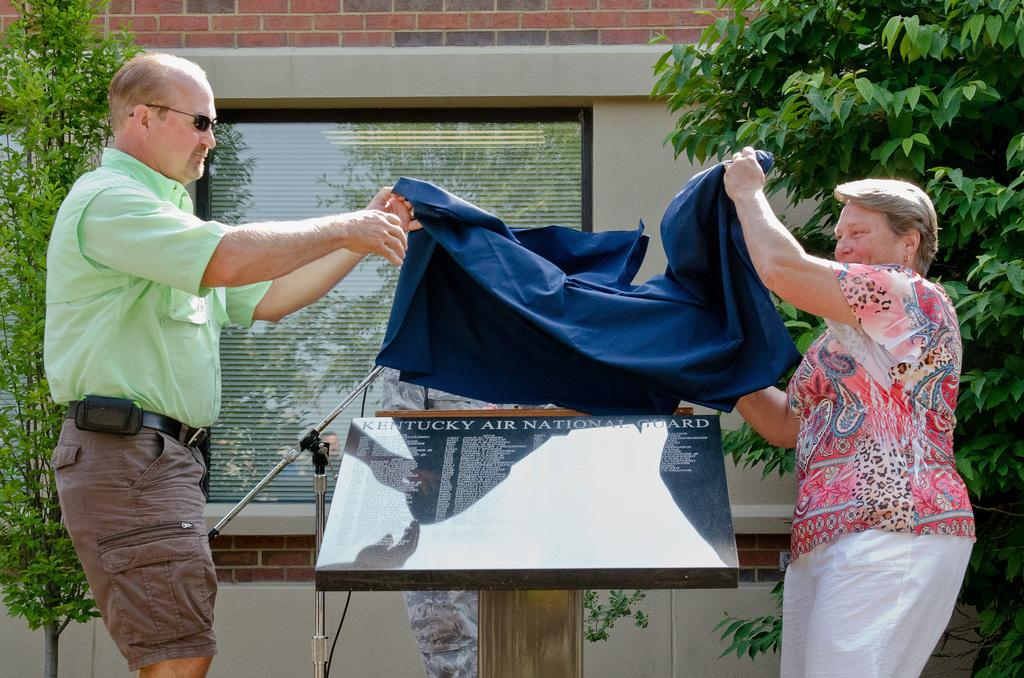How many people are present in the image? There are two people, a man and a woman, present in the image. What are the man and woman holding in the image? The man and woman are holding a cloth in the image. What type of vegetation can be seen in the image? There are trees in the image. What object can be seen in the image that might be used for displaying information or messages? There is a board in the image that could be used for displaying information or messages. What object can be seen in the image that might be used for drinking? There is a glass in the image that could be used for drinking. What is visible in the background of the image? There is a wall in the background of the image. Can you tell me how many worms are swimming in the image? There are no worms or swimming activity depicted in the image. 